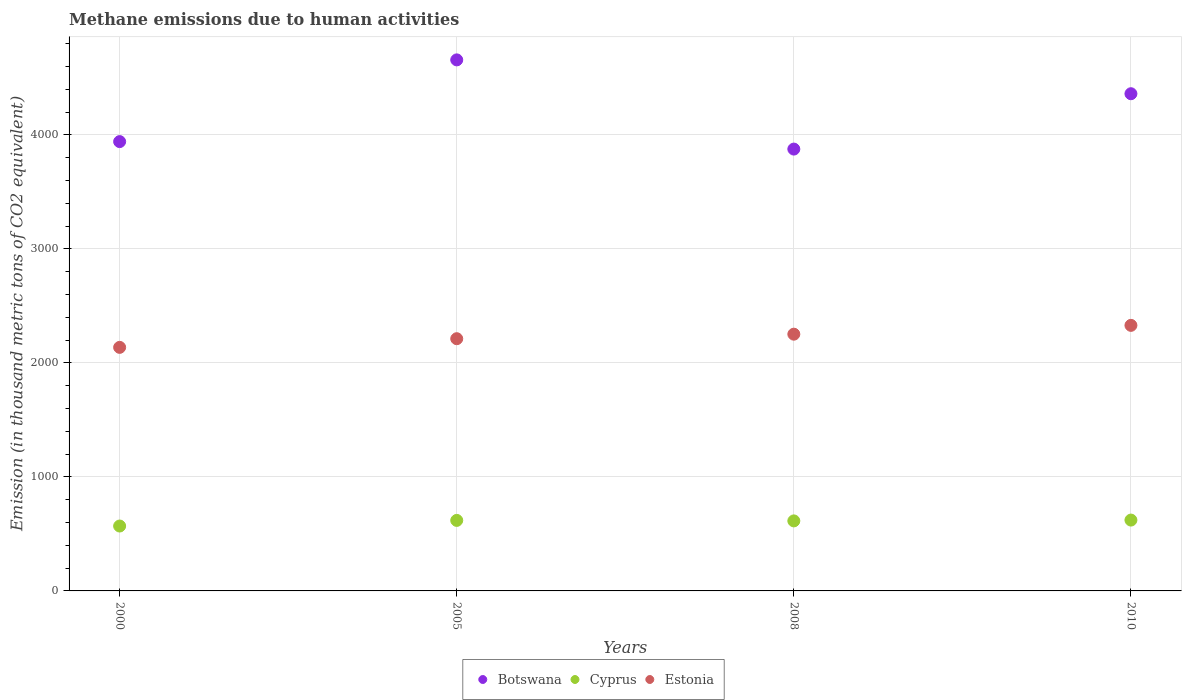How many different coloured dotlines are there?
Your answer should be compact. 3. What is the amount of methane emitted in Estonia in 2008?
Your answer should be very brief. 2252. Across all years, what is the maximum amount of methane emitted in Estonia?
Keep it short and to the point. 2329.3. Across all years, what is the minimum amount of methane emitted in Botswana?
Your answer should be very brief. 3875.5. What is the total amount of methane emitted in Cyprus in the graph?
Your answer should be very brief. 2423.4. What is the difference between the amount of methane emitted in Botswana in 2005 and that in 2010?
Give a very brief answer. 296.9. What is the difference between the amount of methane emitted in Cyprus in 2010 and the amount of methane emitted in Botswana in 2008?
Make the answer very short. -3254.1. What is the average amount of methane emitted in Cyprus per year?
Ensure brevity in your answer.  605.85. In the year 2000, what is the difference between the amount of methane emitted in Cyprus and amount of methane emitted in Botswana?
Give a very brief answer. -3371.9. In how many years, is the amount of methane emitted in Botswana greater than 200 thousand metric tons?
Provide a short and direct response. 4. What is the ratio of the amount of methane emitted in Cyprus in 2000 to that in 2005?
Provide a succinct answer. 0.92. Is the difference between the amount of methane emitted in Cyprus in 2000 and 2008 greater than the difference between the amount of methane emitted in Botswana in 2000 and 2008?
Ensure brevity in your answer.  No. What is the difference between the highest and the second highest amount of methane emitted in Botswana?
Your answer should be very brief. 296.9. What is the difference between the highest and the lowest amount of methane emitted in Cyprus?
Provide a succinct answer. 52.2. Does the amount of methane emitted in Cyprus monotonically increase over the years?
Ensure brevity in your answer.  No. How many dotlines are there?
Provide a short and direct response. 3. Are the values on the major ticks of Y-axis written in scientific E-notation?
Ensure brevity in your answer.  No. Does the graph contain any zero values?
Ensure brevity in your answer.  No. Does the graph contain grids?
Your answer should be compact. Yes. Where does the legend appear in the graph?
Your response must be concise. Bottom center. How many legend labels are there?
Provide a short and direct response. 3. How are the legend labels stacked?
Your response must be concise. Horizontal. What is the title of the graph?
Give a very brief answer. Methane emissions due to human activities. Does "European Union" appear as one of the legend labels in the graph?
Offer a terse response. No. What is the label or title of the Y-axis?
Provide a succinct answer. Emission (in thousand metric tons of CO2 equivalent). What is the Emission (in thousand metric tons of CO2 equivalent) of Botswana in 2000?
Your answer should be very brief. 3941.1. What is the Emission (in thousand metric tons of CO2 equivalent) of Cyprus in 2000?
Make the answer very short. 569.2. What is the Emission (in thousand metric tons of CO2 equivalent) of Estonia in 2000?
Offer a terse response. 2136.3. What is the Emission (in thousand metric tons of CO2 equivalent) in Botswana in 2005?
Give a very brief answer. 4657.9. What is the Emission (in thousand metric tons of CO2 equivalent) of Cyprus in 2005?
Offer a very short reply. 618.6. What is the Emission (in thousand metric tons of CO2 equivalent) of Estonia in 2005?
Offer a terse response. 2212.3. What is the Emission (in thousand metric tons of CO2 equivalent) of Botswana in 2008?
Your answer should be compact. 3875.5. What is the Emission (in thousand metric tons of CO2 equivalent) in Cyprus in 2008?
Keep it short and to the point. 614.2. What is the Emission (in thousand metric tons of CO2 equivalent) of Estonia in 2008?
Your answer should be compact. 2252. What is the Emission (in thousand metric tons of CO2 equivalent) in Botswana in 2010?
Make the answer very short. 4361. What is the Emission (in thousand metric tons of CO2 equivalent) of Cyprus in 2010?
Your answer should be compact. 621.4. What is the Emission (in thousand metric tons of CO2 equivalent) of Estonia in 2010?
Offer a very short reply. 2329.3. Across all years, what is the maximum Emission (in thousand metric tons of CO2 equivalent) in Botswana?
Provide a short and direct response. 4657.9. Across all years, what is the maximum Emission (in thousand metric tons of CO2 equivalent) in Cyprus?
Give a very brief answer. 621.4. Across all years, what is the maximum Emission (in thousand metric tons of CO2 equivalent) of Estonia?
Provide a succinct answer. 2329.3. Across all years, what is the minimum Emission (in thousand metric tons of CO2 equivalent) in Botswana?
Offer a very short reply. 3875.5. Across all years, what is the minimum Emission (in thousand metric tons of CO2 equivalent) in Cyprus?
Your answer should be compact. 569.2. Across all years, what is the minimum Emission (in thousand metric tons of CO2 equivalent) in Estonia?
Ensure brevity in your answer.  2136.3. What is the total Emission (in thousand metric tons of CO2 equivalent) in Botswana in the graph?
Provide a succinct answer. 1.68e+04. What is the total Emission (in thousand metric tons of CO2 equivalent) in Cyprus in the graph?
Your answer should be compact. 2423.4. What is the total Emission (in thousand metric tons of CO2 equivalent) of Estonia in the graph?
Provide a short and direct response. 8929.9. What is the difference between the Emission (in thousand metric tons of CO2 equivalent) of Botswana in 2000 and that in 2005?
Make the answer very short. -716.8. What is the difference between the Emission (in thousand metric tons of CO2 equivalent) of Cyprus in 2000 and that in 2005?
Provide a short and direct response. -49.4. What is the difference between the Emission (in thousand metric tons of CO2 equivalent) of Estonia in 2000 and that in 2005?
Keep it short and to the point. -76. What is the difference between the Emission (in thousand metric tons of CO2 equivalent) in Botswana in 2000 and that in 2008?
Provide a short and direct response. 65.6. What is the difference between the Emission (in thousand metric tons of CO2 equivalent) of Cyprus in 2000 and that in 2008?
Keep it short and to the point. -45. What is the difference between the Emission (in thousand metric tons of CO2 equivalent) in Estonia in 2000 and that in 2008?
Offer a terse response. -115.7. What is the difference between the Emission (in thousand metric tons of CO2 equivalent) of Botswana in 2000 and that in 2010?
Give a very brief answer. -419.9. What is the difference between the Emission (in thousand metric tons of CO2 equivalent) of Cyprus in 2000 and that in 2010?
Provide a short and direct response. -52.2. What is the difference between the Emission (in thousand metric tons of CO2 equivalent) in Estonia in 2000 and that in 2010?
Provide a short and direct response. -193. What is the difference between the Emission (in thousand metric tons of CO2 equivalent) in Botswana in 2005 and that in 2008?
Offer a very short reply. 782.4. What is the difference between the Emission (in thousand metric tons of CO2 equivalent) of Estonia in 2005 and that in 2008?
Offer a very short reply. -39.7. What is the difference between the Emission (in thousand metric tons of CO2 equivalent) in Botswana in 2005 and that in 2010?
Your answer should be compact. 296.9. What is the difference between the Emission (in thousand metric tons of CO2 equivalent) in Cyprus in 2005 and that in 2010?
Your response must be concise. -2.8. What is the difference between the Emission (in thousand metric tons of CO2 equivalent) in Estonia in 2005 and that in 2010?
Offer a very short reply. -117. What is the difference between the Emission (in thousand metric tons of CO2 equivalent) in Botswana in 2008 and that in 2010?
Provide a short and direct response. -485.5. What is the difference between the Emission (in thousand metric tons of CO2 equivalent) of Estonia in 2008 and that in 2010?
Keep it short and to the point. -77.3. What is the difference between the Emission (in thousand metric tons of CO2 equivalent) of Botswana in 2000 and the Emission (in thousand metric tons of CO2 equivalent) of Cyprus in 2005?
Your answer should be compact. 3322.5. What is the difference between the Emission (in thousand metric tons of CO2 equivalent) of Botswana in 2000 and the Emission (in thousand metric tons of CO2 equivalent) of Estonia in 2005?
Give a very brief answer. 1728.8. What is the difference between the Emission (in thousand metric tons of CO2 equivalent) of Cyprus in 2000 and the Emission (in thousand metric tons of CO2 equivalent) of Estonia in 2005?
Your answer should be very brief. -1643.1. What is the difference between the Emission (in thousand metric tons of CO2 equivalent) of Botswana in 2000 and the Emission (in thousand metric tons of CO2 equivalent) of Cyprus in 2008?
Your response must be concise. 3326.9. What is the difference between the Emission (in thousand metric tons of CO2 equivalent) of Botswana in 2000 and the Emission (in thousand metric tons of CO2 equivalent) of Estonia in 2008?
Make the answer very short. 1689.1. What is the difference between the Emission (in thousand metric tons of CO2 equivalent) of Cyprus in 2000 and the Emission (in thousand metric tons of CO2 equivalent) of Estonia in 2008?
Keep it short and to the point. -1682.8. What is the difference between the Emission (in thousand metric tons of CO2 equivalent) of Botswana in 2000 and the Emission (in thousand metric tons of CO2 equivalent) of Cyprus in 2010?
Offer a terse response. 3319.7. What is the difference between the Emission (in thousand metric tons of CO2 equivalent) in Botswana in 2000 and the Emission (in thousand metric tons of CO2 equivalent) in Estonia in 2010?
Ensure brevity in your answer.  1611.8. What is the difference between the Emission (in thousand metric tons of CO2 equivalent) of Cyprus in 2000 and the Emission (in thousand metric tons of CO2 equivalent) of Estonia in 2010?
Offer a very short reply. -1760.1. What is the difference between the Emission (in thousand metric tons of CO2 equivalent) of Botswana in 2005 and the Emission (in thousand metric tons of CO2 equivalent) of Cyprus in 2008?
Your answer should be very brief. 4043.7. What is the difference between the Emission (in thousand metric tons of CO2 equivalent) of Botswana in 2005 and the Emission (in thousand metric tons of CO2 equivalent) of Estonia in 2008?
Provide a succinct answer. 2405.9. What is the difference between the Emission (in thousand metric tons of CO2 equivalent) of Cyprus in 2005 and the Emission (in thousand metric tons of CO2 equivalent) of Estonia in 2008?
Make the answer very short. -1633.4. What is the difference between the Emission (in thousand metric tons of CO2 equivalent) in Botswana in 2005 and the Emission (in thousand metric tons of CO2 equivalent) in Cyprus in 2010?
Offer a terse response. 4036.5. What is the difference between the Emission (in thousand metric tons of CO2 equivalent) in Botswana in 2005 and the Emission (in thousand metric tons of CO2 equivalent) in Estonia in 2010?
Give a very brief answer. 2328.6. What is the difference between the Emission (in thousand metric tons of CO2 equivalent) in Cyprus in 2005 and the Emission (in thousand metric tons of CO2 equivalent) in Estonia in 2010?
Make the answer very short. -1710.7. What is the difference between the Emission (in thousand metric tons of CO2 equivalent) of Botswana in 2008 and the Emission (in thousand metric tons of CO2 equivalent) of Cyprus in 2010?
Ensure brevity in your answer.  3254.1. What is the difference between the Emission (in thousand metric tons of CO2 equivalent) in Botswana in 2008 and the Emission (in thousand metric tons of CO2 equivalent) in Estonia in 2010?
Keep it short and to the point. 1546.2. What is the difference between the Emission (in thousand metric tons of CO2 equivalent) of Cyprus in 2008 and the Emission (in thousand metric tons of CO2 equivalent) of Estonia in 2010?
Your response must be concise. -1715.1. What is the average Emission (in thousand metric tons of CO2 equivalent) in Botswana per year?
Keep it short and to the point. 4208.88. What is the average Emission (in thousand metric tons of CO2 equivalent) in Cyprus per year?
Provide a succinct answer. 605.85. What is the average Emission (in thousand metric tons of CO2 equivalent) of Estonia per year?
Your answer should be very brief. 2232.47. In the year 2000, what is the difference between the Emission (in thousand metric tons of CO2 equivalent) in Botswana and Emission (in thousand metric tons of CO2 equivalent) in Cyprus?
Ensure brevity in your answer.  3371.9. In the year 2000, what is the difference between the Emission (in thousand metric tons of CO2 equivalent) of Botswana and Emission (in thousand metric tons of CO2 equivalent) of Estonia?
Your answer should be compact. 1804.8. In the year 2000, what is the difference between the Emission (in thousand metric tons of CO2 equivalent) in Cyprus and Emission (in thousand metric tons of CO2 equivalent) in Estonia?
Offer a terse response. -1567.1. In the year 2005, what is the difference between the Emission (in thousand metric tons of CO2 equivalent) of Botswana and Emission (in thousand metric tons of CO2 equivalent) of Cyprus?
Keep it short and to the point. 4039.3. In the year 2005, what is the difference between the Emission (in thousand metric tons of CO2 equivalent) of Botswana and Emission (in thousand metric tons of CO2 equivalent) of Estonia?
Your response must be concise. 2445.6. In the year 2005, what is the difference between the Emission (in thousand metric tons of CO2 equivalent) of Cyprus and Emission (in thousand metric tons of CO2 equivalent) of Estonia?
Make the answer very short. -1593.7. In the year 2008, what is the difference between the Emission (in thousand metric tons of CO2 equivalent) in Botswana and Emission (in thousand metric tons of CO2 equivalent) in Cyprus?
Offer a very short reply. 3261.3. In the year 2008, what is the difference between the Emission (in thousand metric tons of CO2 equivalent) of Botswana and Emission (in thousand metric tons of CO2 equivalent) of Estonia?
Offer a very short reply. 1623.5. In the year 2008, what is the difference between the Emission (in thousand metric tons of CO2 equivalent) in Cyprus and Emission (in thousand metric tons of CO2 equivalent) in Estonia?
Offer a very short reply. -1637.8. In the year 2010, what is the difference between the Emission (in thousand metric tons of CO2 equivalent) in Botswana and Emission (in thousand metric tons of CO2 equivalent) in Cyprus?
Your response must be concise. 3739.6. In the year 2010, what is the difference between the Emission (in thousand metric tons of CO2 equivalent) of Botswana and Emission (in thousand metric tons of CO2 equivalent) of Estonia?
Offer a very short reply. 2031.7. In the year 2010, what is the difference between the Emission (in thousand metric tons of CO2 equivalent) in Cyprus and Emission (in thousand metric tons of CO2 equivalent) in Estonia?
Provide a short and direct response. -1707.9. What is the ratio of the Emission (in thousand metric tons of CO2 equivalent) of Botswana in 2000 to that in 2005?
Offer a very short reply. 0.85. What is the ratio of the Emission (in thousand metric tons of CO2 equivalent) of Cyprus in 2000 to that in 2005?
Make the answer very short. 0.92. What is the ratio of the Emission (in thousand metric tons of CO2 equivalent) in Estonia in 2000 to that in 2005?
Your answer should be very brief. 0.97. What is the ratio of the Emission (in thousand metric tons of CO2 equivalent) in Botswana in 2000 to that in 2008?
Offer a very short reply. 1.02. What is the ratio of the Emission (in thousand metric tons of CO2 equivalent) in Cyprus in 2000 to that in 2008?
Give a very brief answer. 0.93. What is the ratio of the Emission (in thousand metric tons of CO2 equivalent) of Estonia in 2000 to that in 2008?
Keep it short and to the point. 0.95. What is the ratio of the Emission (in thousand metric tons of CO2 equivalent) in Botswana in 2000 to that in 2010?
Offer a very short reply. 0.9. What is the ratio of the Emission (in thousand metric tons of CO2 equivalent) in Cyprus in 2000 to that in 2010?
Offer a terse response. 0.92. What is the ratio of the Emission (in thousand metric tons of CO2 equivalent) of Estonia in 2000 to that in 2010?
Give a very brief answer. 0.92. What is the ratio of the Emission (in thousand metric tons of CO2 equivalent) in Botswana in 2005 to that in 2008?
Make the answer very short. 1.2. What is the ratio of the Emission (in thousand metric tons of CO2 equivalent) of Estonia in 2005 to that in 2008?
Make the answer very short. 0.98. What is the ratio of the Emission (in thousand metric tons of CO2 equivalent) in Botswana in 2005 to that in 2010?
Give a very brief answer. 1.07. What is the ratio of the Emission (in thousand metric tons of CO2 equivalent) in Cyprus in 2005 to that in 2010?
Provide a succinct answer. 1. What is the ratio of the Emission (in thousand metric tons of CO2 equivalent) in Estonia in 2005 to that in 2010?
Keep it short and to the point. 0.95. What is the ratio of the Emission (in thousand metric tons of CO2 equivalent) in Botswana in 2008 to that in 2010?
Offer a very short reply. 0.89. What is the ratio of the Emission (in thousand metric tons of CO2 equivalent) of Cyprus in 2008 to that in 2010?
Give a very brief answer. 0.99. What is the ratio of the Emission (in thousand metric tons of CO2 equivalent) of Estonia in 2008 to that in 2010?
Ensure brevity in your answer.  0.97. What is the difference between the highest and the second highest Emission (in thousand metric tons of CO2 equivalent) of Botswana?
Your response must be concise. 296.9. What is the difference between the highest and the second highest Emission (in thousand metric tons of CO2 equivalent) of Estonia?
Give a very brief answer. 77.3. What is the difference between the highest and the lowest Emission (in thousand metric tons of CO2 equivalent) in Botswana?
Provide a short and direct response. 782.4. What is the difference between the highest and the lowest Emission (in thousand metric tons of CO2 equivalent) of Cyprus?
Offer a terse response. 52.2. What is the difference between the highest and the lowest Emission (in thousand metric tons of CO2 equivalent) of Estonia?
Ensure brevity in your answer.  193. 